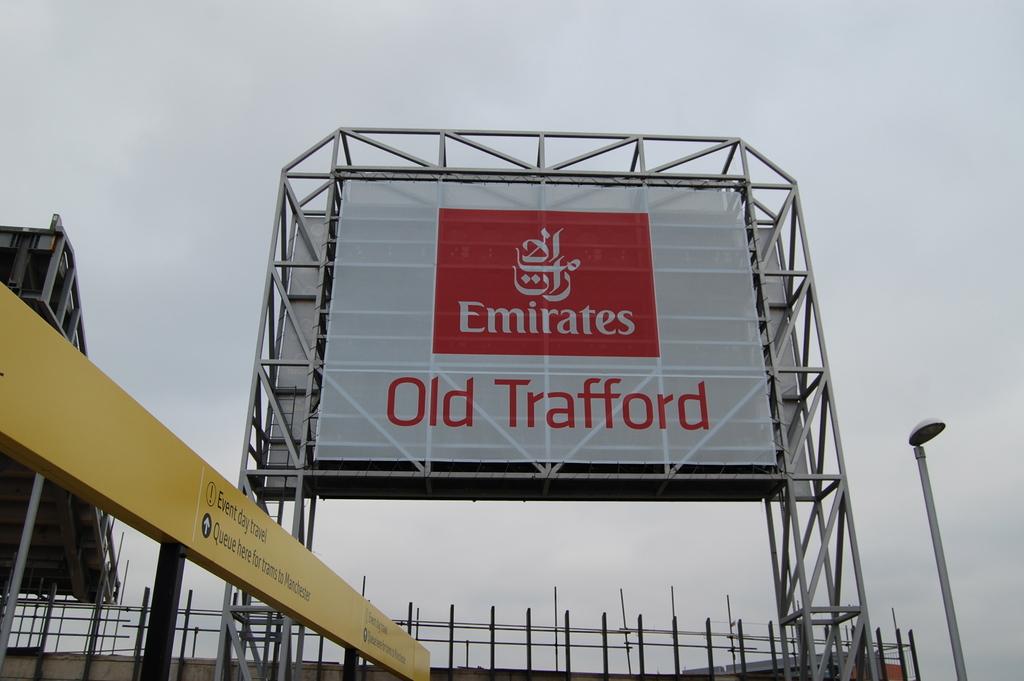What brand is represented on the red rectangle?
Keep it short and to the point. Emirates. What name comes after old?
Offer a very short reply. Trafford. 